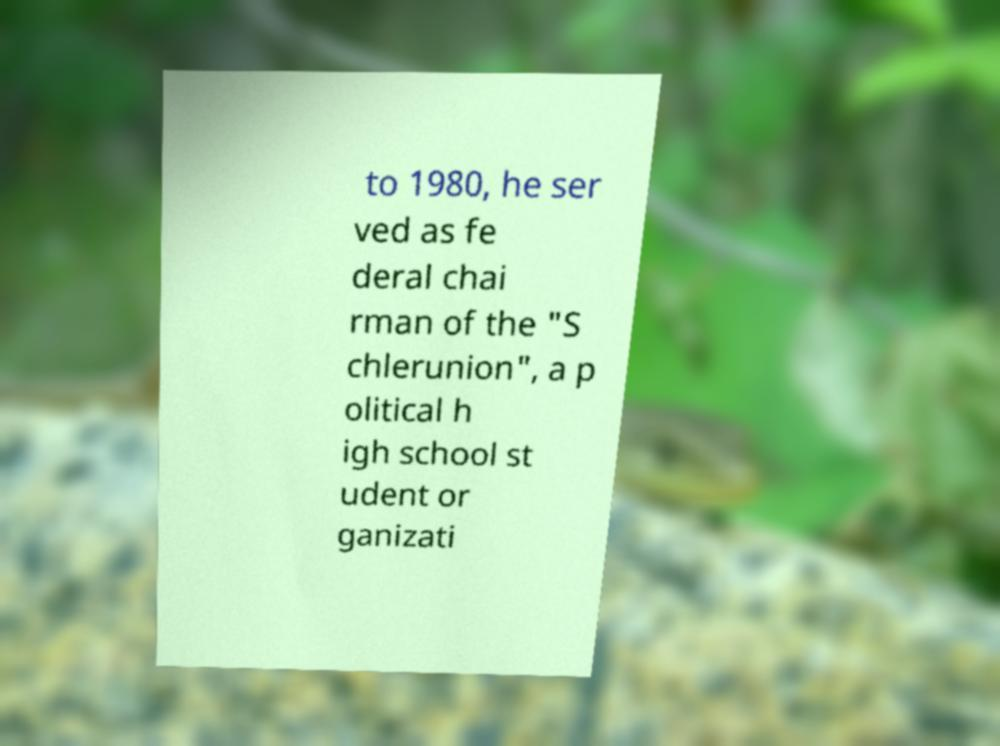Could you assist in decoding the text presented in this image and type it out clearly? to 1980, he ser ved as fe deral chai rman of the "S chlerunion", a p olitical h igh school st udent or ganizati 